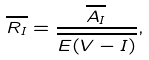Convert formula to latex. <formula><loc_0><loc_0><loc_500><loc_500>\overline { R _ { I } } = \frac { \overline { A _ { I } } } { \overline { E ( V - I ) } } ,</formula> 